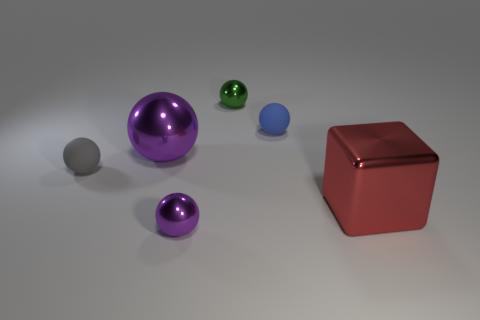How would the lighting affect the appearance of these objects if one of them were to be moved? If you moved any of the objects, their appearance would change due to the lighting. Shiny objects would reflect light differently, creating new highlights and shadows. If the object moved blocks light, it could cast a shadow on other objects, altering their visibility and the overall composition of the scene. Which object would show the most dramatic change if moved? The large purple metallic ball would likely show the most dramatic change. Its shiny surface is highly reflective, so moving it could greatly affect the light dynamics in the scene, including the reflections seen on its surface and how it casts light onto nearby objects. 